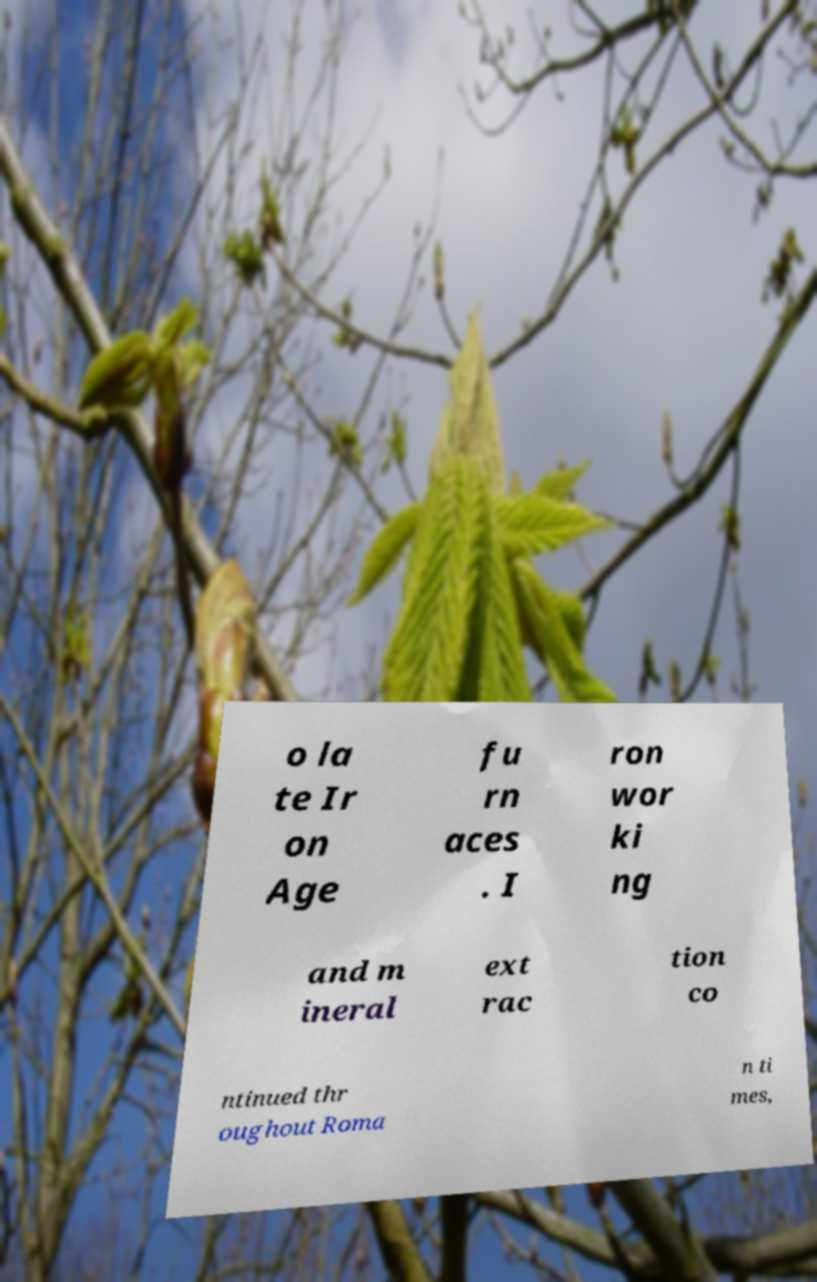Can you read and provide the text displayed in the image?This photo seems to have some interesting text. Can you extract and type it out for me? o la te Ir on Age fu rn aces . I ron wor ki ng and m ineral ext rac tion co ntinued thr oughout Roma n ti mes, 